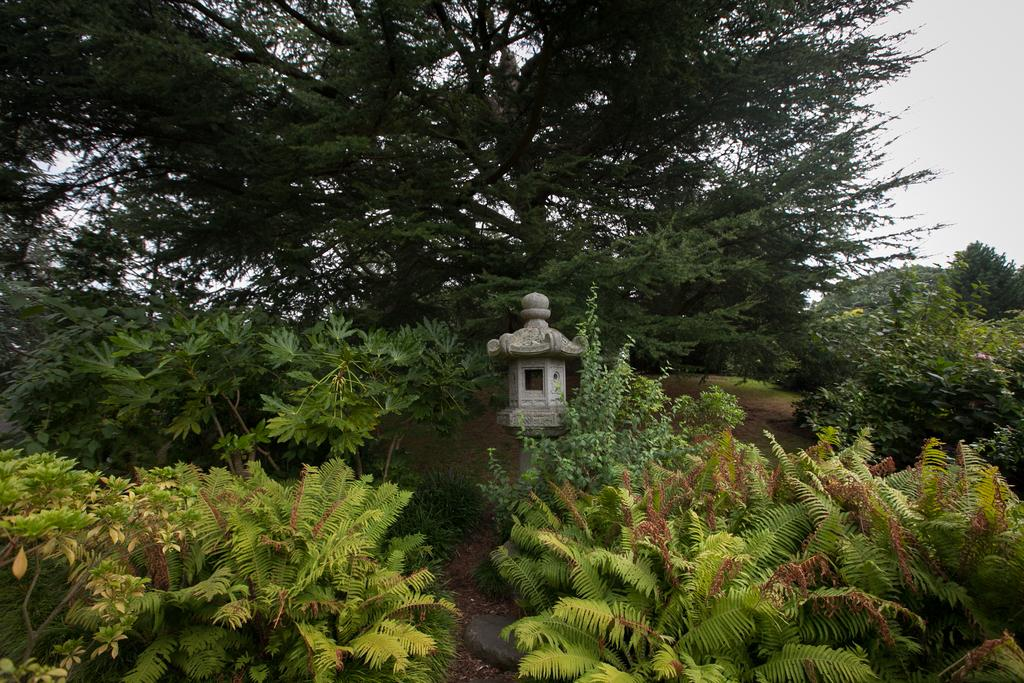What type of natural elements are present in the image? There are trees and plants in the image. What can be seen in the middle of the image? There is a white color thing in the middle of the image. What is visible in the background of the image? The sky is visible in the background of the image. What type of steel industry can be seen in the image? There is no steel industry present in the image; it features trees, plants, and a white color thing in the middle. How many team members are visible in the image? There are no team members present in the image. 